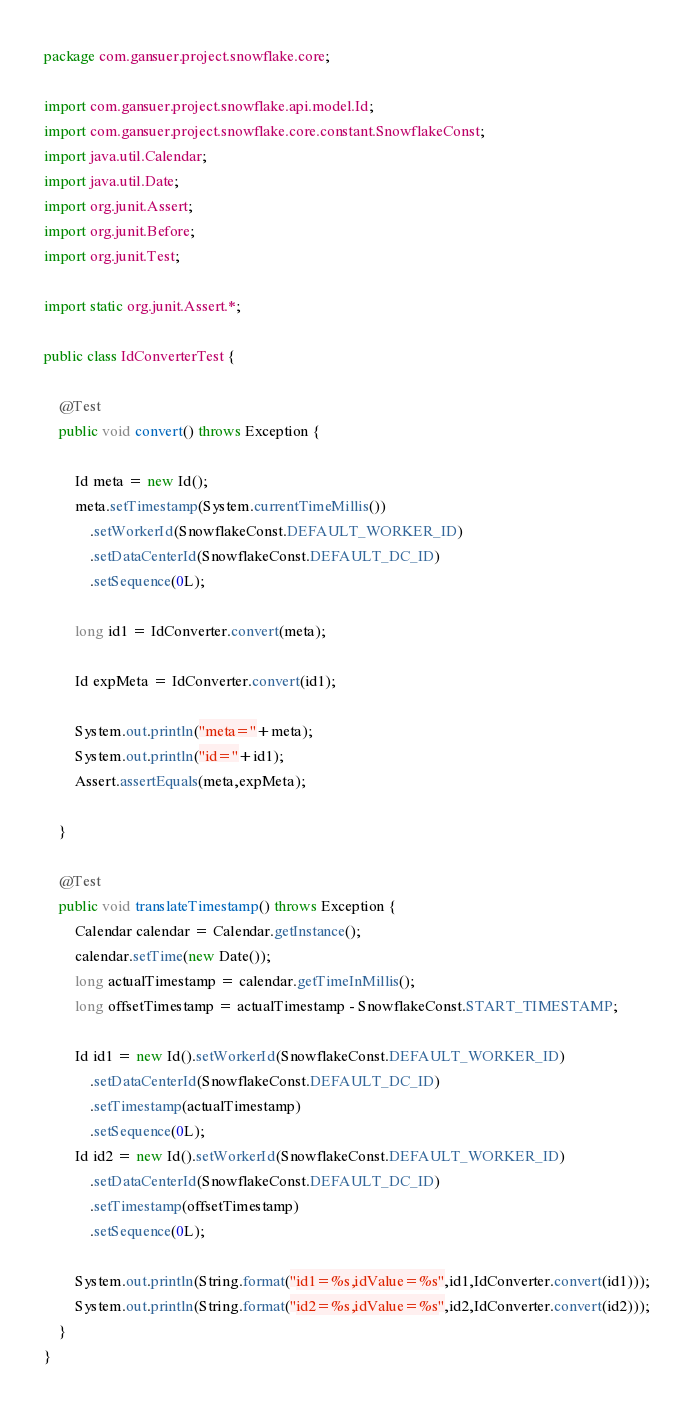Convert code to text. <code><loc_0><loc_0><loc_500><loc_500><_Java_>package com.gansuer.project.snowflake.core;

import com.gansuer.project.snowflake.api.model.Id;
import com.gansuer.project.snowflake.core.constant.SnowflakeConst;
import java.util.Calendar;
import java.util.Date;
import org.junit.Assert;
import org.junit.Before;
import org.junit.Test;

import static org.junit.Assert.*;

public class IdConverterTest {

    @Test
    public void convert() throws Exception {

        Id meta = new Id();
        meta.setTimestamp(System.currentTimeMillis())
            .setWorkerId(SnowflakeConst.DEFAULT_WORKER_ID)
            .setDataCenterId(SnowflakeConst.DEFAULT_DC_ID)
            .setSequence(0L);

        long id1 = IdConverter.convert(meta);

        Id expMeta = IdConverter.convert(id1);

        System.out.println("meta="+meta);
        System.out.println("id="+id1);
        Assert.assertEquals(meta,expMeta);

    }

    @Test
    public void translateTimestamp() throws Exception {
        Calendar calendar = Calendar.getInstance();
        calendar.setTime(new Date());
        long actualTimestamp = calendar.getTimeInMillis();
        long offsetTimestamp = actualTimestamp - SnowflakeConst.START_TIMESTAMP;

        Id id1 = new Id().setWorkerId(SnowflakeConst.DEFAULT_WORKER_ID)
            .setDataCenterId(SnowflakeConst.DEFAULT_DC_ID)
            .setTimestamp(actualTimestamp)
            .setSequence(0L);
        Id id2 = new Id().setWorkerId(SnowflakeConst.DEFAULT_WORKER_ID)
            .setDataCenterId(SnowflakeConst.DEFAULT_DC_ID)
            .setTimestamp(offsetTimestamp)
            .setSequence(0L);

        System.out.println(String.format("id1=%s,idValue=%s",id1,IdConverter.convert(id1)));
        System.out.println(String.format("id2=%s,idValue=%s",id2,IdConverter.convert(id2)));
    }
}</code> 